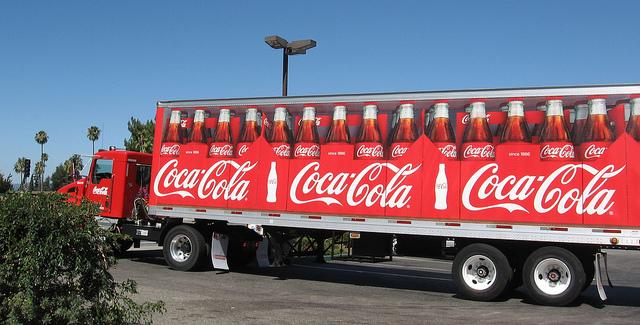Is the streetlight on?
Short answer required. No. What is on the truck?
Concise answer only. Coca cola. What company do they work for?
Concise answer only. Coca cola. 